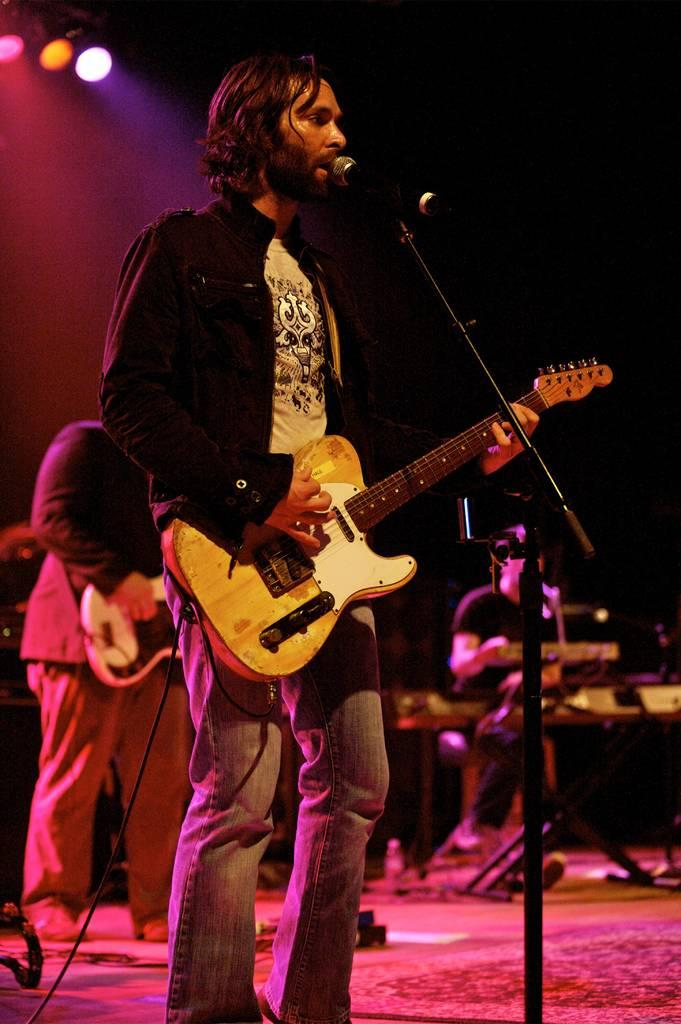What is the person in the image wearing? The person is wearing a black dress in the image. What is the person doing in the image? The person is playing a guitar in the image. What object is the person in front of? The person is in front of a microphone in the image. What other musical activity is happening in the background? There is a person playing a piano in the background. How many sacks are being used by the person playing the guitar in the image? There are no sacks present in the image; the person is playing a guitar and standing in front of a microphone. 